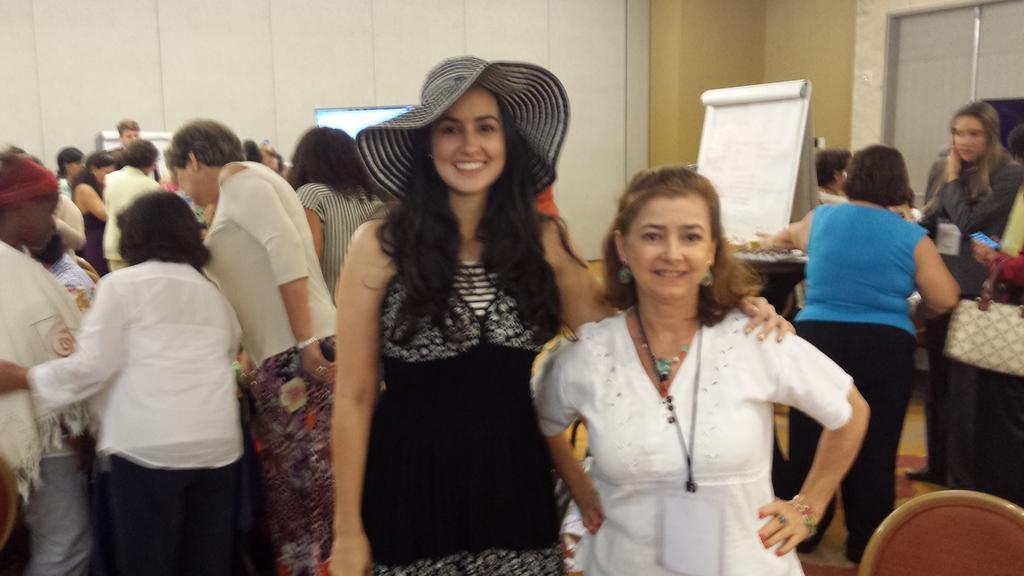Describe this image in one or two sentences. In this image there are two girls standing with a smile on their face, behind them there are a few more people standing, in between them there is a banner, chairs and screen. In the background there is a wall. 